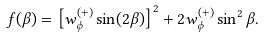<formula> <loc_0><loc_0><loc_500><loc_500>f ( \beta ) = \left [ w ^ { ( + ) } _ { \phi } \sin ( 2 \beta ) \right ] ^ { 2 } + 2 w ^ { ( + ) } _ { \phi } \sin ^ { 2 } \beta .</formula> 